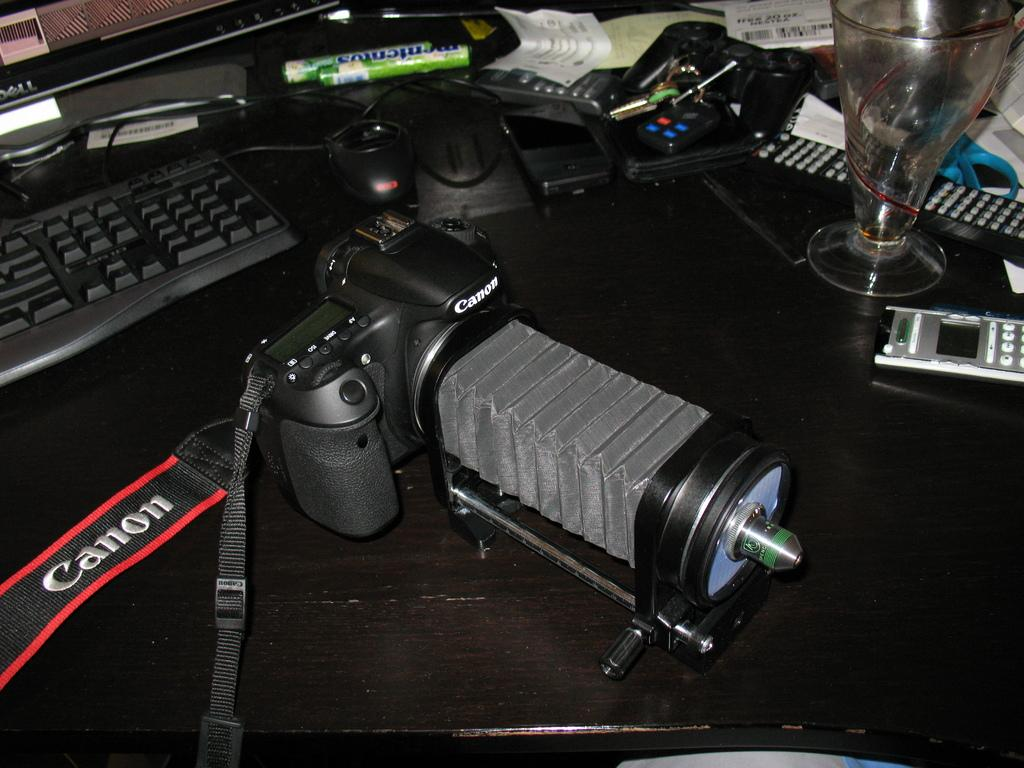What type of crown is being rubbed against the wall in the image? There is no crown or wall present in the image, so it is not possible to answer that question. 